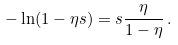Convert formula to latex. <formula><loc_0><loc_0><loc_500><loc_500>- \ln ( 1 - \eta s ) = s \frac { \eta } { 1 - \eta } \, .</formula> 